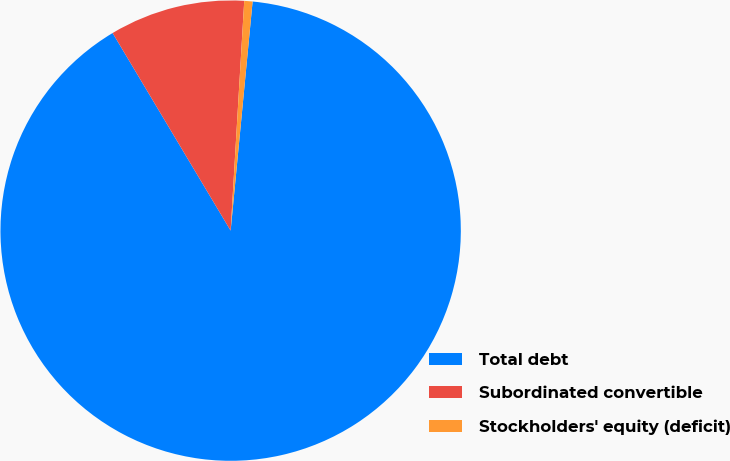Convert chart to OTSL. <chart><loc_0><loc_0><loc_500><loc_500><pie_chart><fcel>Total debt<fcel>Subordinated convertible<fcel>Stockholders' equity (deficit)<nl><fcel>89.91%<fcel>9.51%<fcel>0.58%<nl></chart> 